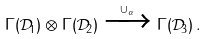<formula> <loc_0><loc_0><loc_500><loc_500>\Gamma ( \mathcal { D } _ { 1 } ) \otimes \Gamma ( \mathcal { D } _ { 2 } ) \xrightarrow { \cup _ { \alpha } } \Gamma ( \mathcal { D } _ { 3 } ) \, .</formula> 